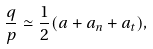<formula> <loc_0><loc_0><loc_500><loc_500>\frac { q } { p } \simeq \frac { 1 } { 2 } ( a + a _ { n } + a _ { t } ) ,</formula> 